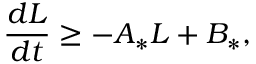<formula> <loc_0><loc_0><loc_500><loc_500>\frac { d L } { d t } \geq - A _ { * } L + B _ { * } ,</formula> 